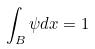Convert formula to latex. <formula><loc_0><loc_0><loc_500><loc_500>\int _ { B } \psi d x = 1</formula> 